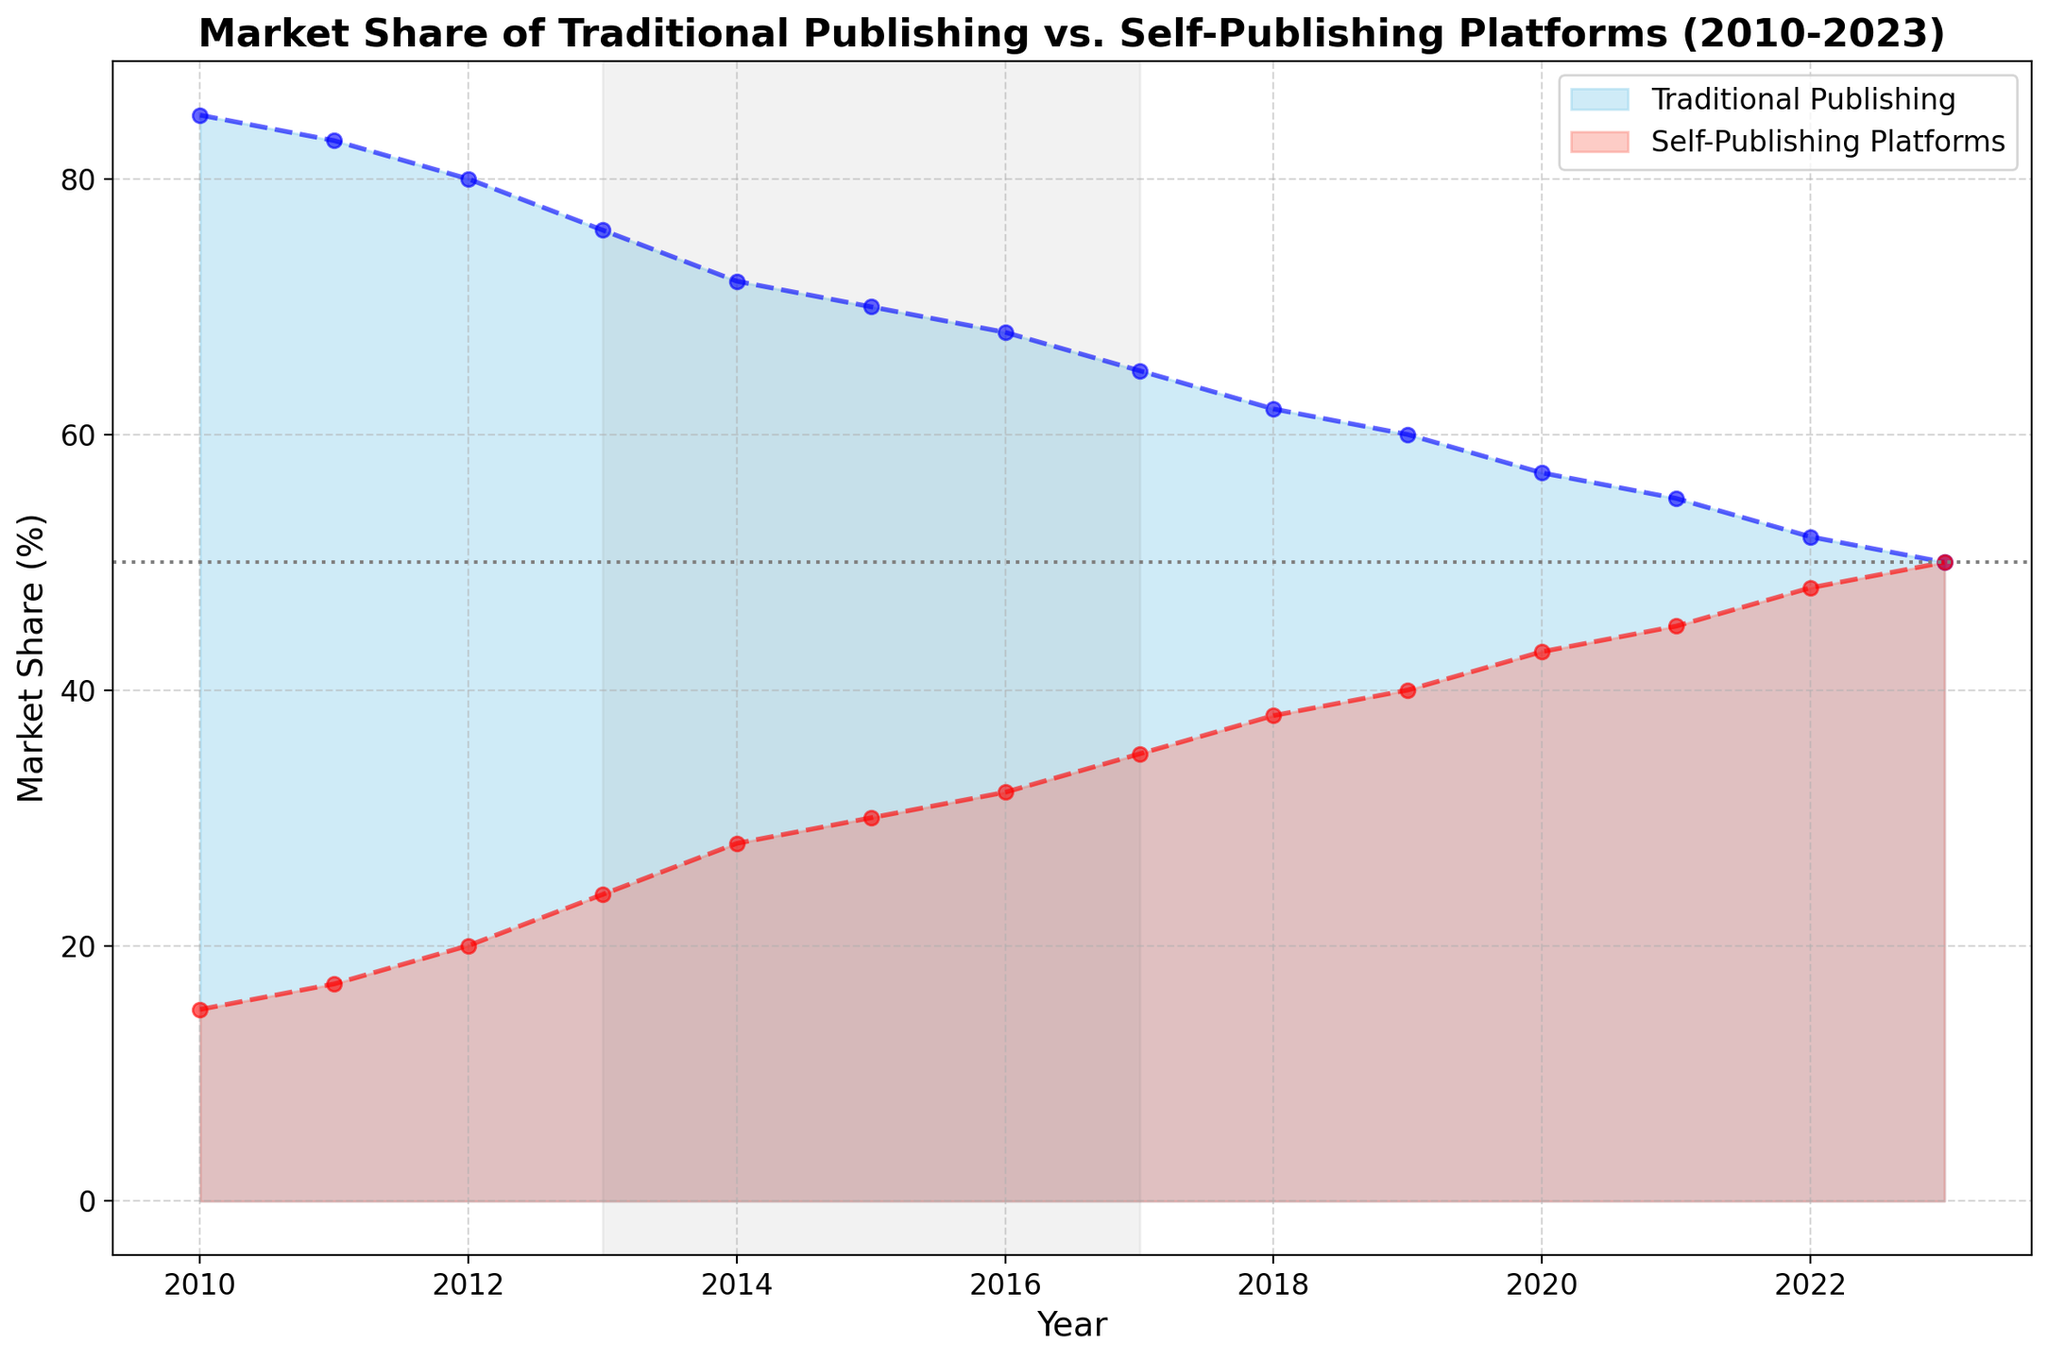What trend can be observed in the market share of Traditional Publishing from 2010 to 2023? The market share of Traditional Publishing decreases consistently over the years. Looking at the visual, the blue area representing Traditional Publishing shrinks over time, beginning at 85% in 2010 and reducing to 50% in 2023.
Answer: Decreasing Which year shows an equal market share between Traditional Publishing and Self-Publishing Platforms? The equal market share is identified where the two areas intersect visually. Both areas intersect at the year 2023, indicating equal market share at this point.
Answer: 2023 Between which years did the market share of Self-Publishing Platforms increase the most rapidly? By comparing the slopes of the red area in the visual, the steepest increase appears between 2012 and 2014. The market share jumped from 20% in 2012 to 28% in 2014.
Answer: 2012 to 2014 By how much did the market share of Traditional Publishing exceed that of Self-Publishing Platforms in 2015? Referring to the values from the chart, Traditional Publishing had a market share of 70% and Self-Publishing Platforms had 30% in 2015. The difference is 70% - 30%.
Answer: 40% During which time span did the Traditional Publishing market share decrease by 30%? From the chart, Traditional Publishing starts at 85% in 2010 and reaches 55% in 2021. The difference here is 85% - 55%, which is 30%.
Answer: 2010 to 2021 What is the average market share of Self-Publishing Platforms over the entire period? To calculate the average market share: sum of shares from 2010-2023 is (15 + 17 + 20 + 24 + 28 + 30 + 32 + 35 + 38 + 40 + 43 + 45 + 48 + 50) = 465. Divide by 14 years: 465/14 ≈ 33.2%
Answer: 33.2% Which segment dominated the market in 2017? The visual comparison shows the blue area (Traditional Publishing) is larger than the red area (Self-Publishing) in 2017. Hence, Traditional Publishing dominated in 2017.
Answer: Traditional Publishing By how much did the Self-Publishing market share increase from 2010 to 2020? Referring to the values in the chart: Self-Publishing was at 15% in 2010 and increased to 43% in 2020. The difference is 43% - 15%.
Answer: 28% Which year marked the beginning of Traditional Publishing's market share dropping below 70%? Observing the chart, Traditional Publishing's market share first drops below 70% in the year 2015. Prior to that, it remained above 70%.
Answer: 2015 In which periods does the gray shaded area on the chart fall, and what significance might it hold? The gray shaded area spans from 2013 to 2017. This period could signify a notable shift or significant events influencing market shares, with a faster rise of Self-Publishing Platforms and a decline in Traditional Publishing.
Answer: 2013-2017 